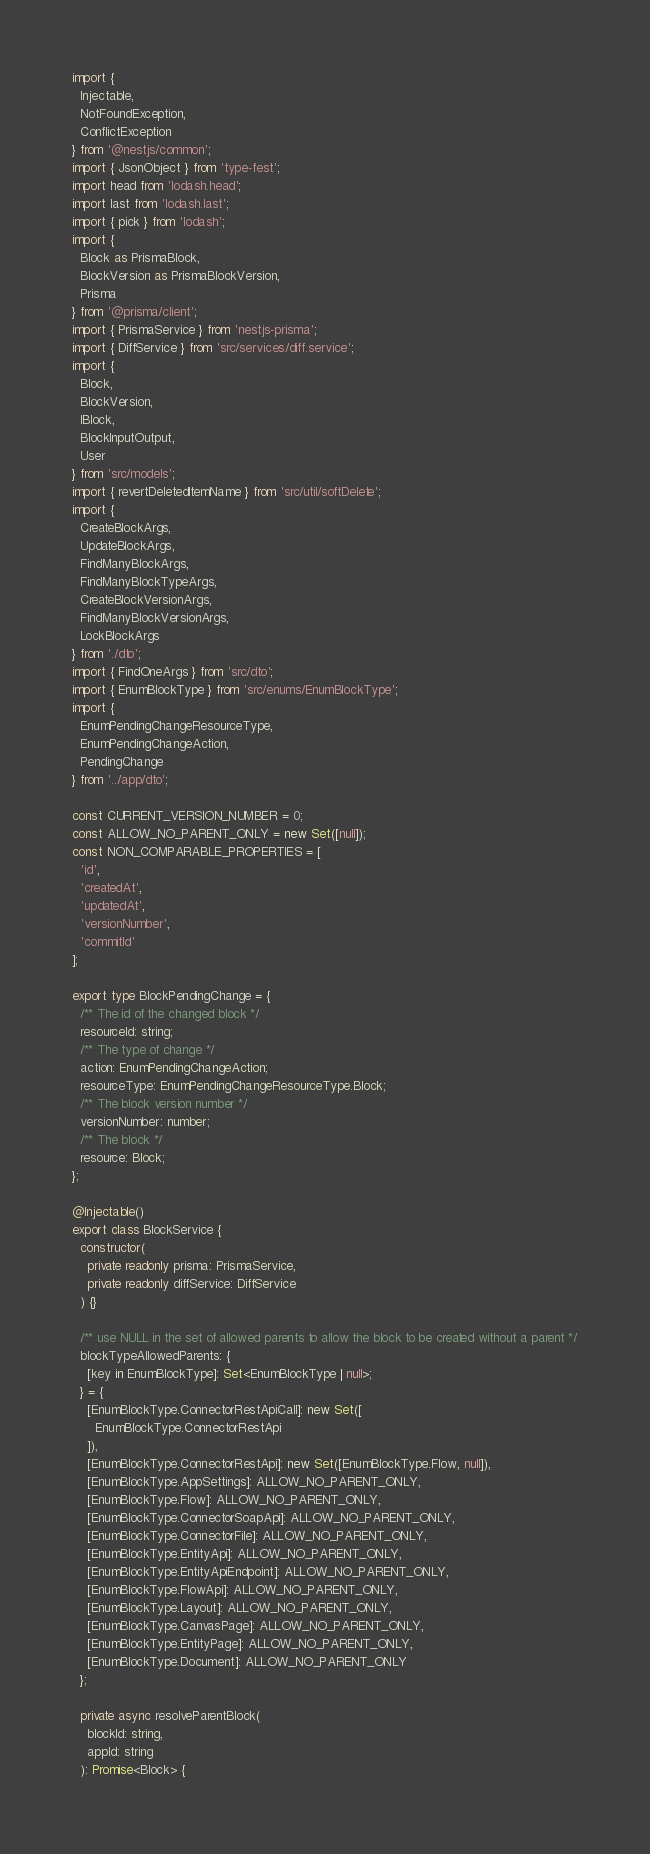<code> <loc_0><loc_0><loc_500><loc_500><_TypeScript_>import {
  Injectable,
  NotFoundException,
  ConflictException
} from '@nestjs/common';
import { JsonObject } from 'type-fest';
import head from 'lodash.head';
import last from 'lodash.last';
import { pick } from 'lodash';
import {
  Block as PrismaBlock,
  BlockVersion as PrismaBlockVersion,
  Prisma
} from '@prisma/client';
import { PrismaService } from 'nestjs-prisma';
import { DiffService } from 'src/services/diff.service';
import {
  Block,
  BlockVersion,
  IBlock,
  BlockInputOutput,
  User
} from 'src/models';
import { revertDeletedItemName } from 'src/util/softDelete';
import {
  CreateBlockArgs,
  UpdateBlockArgs,
  FindManyBlockArgs,
  FindManyBlockTypeArgs,
  CreateBlockVersionArgs,
  FindManyBlockVersionArgs,
  LockBlockArgs
} from './dto';
import { FindOneArgs } from 'src/dto';
import { EnumBlockType } from 'src/enums/EnumBlockType';
import {
  EnumPendingChangeResourceType,
  EnumPendingChangeAction,
  PendingChange
} from '../app/dto';

const CURRENT_VERSION_NUMBER = 0;
const ALLOW_NO_PARENT_ONLY = new Set([null]);
const NON_COMPARABLE_PROPERTIES = [
  'id',
  'createdAt',
  'updatedAt',
  'versionNumber',
  'commitId'
];

export type BlockPendingChange = {
  /** The id of the changed block */
  resourceId: string;
  /** The type of change */
  action: EnumPendingChangeAction;
  resourceType: EnumPendingChangeResourceType.Block;
  /** The block version number */
  versionNumber: number;
  /** The block */
  resource: Block;
};

@Injectable()
export class BlockService {
  constructor(
    private readonly prisma: PrismaService,
    private readonly diffService: DiffService
  ) {}

  /** use NULL in the set of allowed parents to allow the block to be created without a parent */
  blockTypeAllowedParents: {
    [key in EnumBlockType]: Set<EnumBlockType | null>;
  } = {
    [EnumBlockType.ConnectorRestApiCall]: new Set([
      EnumBlockType.ConnectorRestApi
    ]),
    [EnumBlockType.ConnectorRestApi]: new Set([EnumBlockType.Flow, null]),
    [EnumBlockType.AppSettings]: ALLOW_NO_PARENT_ONLY,
    [EnumBlockType.Flow]: ALLOW_NO_PARENT_ONLY,
    [EnumBlockType.ConnectorSoapApi]: ALLOW_NO_PARENT_ONLY,
    [EnumBlockType.ConnectorFile]: ALLOW_NO_PARENT_ONLY,
    [EnumBlockType.EntityApi]: ALLOW_NO_PARENT_ONLY,
    [EnumBlockType.EntityApiEndpoint]: ALLOW_NO_PARENT_ONLY,
    [EnumBlockType.FlowApi]: ALLOW_NO_PARENT_ONLY,
    [EnumBlockType.Layout]: ALLOW_NO_PARENT_ONLY,
    [EnumBlockType.CanvasPage]: ALLOW_NO_PARENT_ONLY,
    [EnumBlockType.EntityPage]: ALLOW_NO_PARENT_ONLY,
    [EnumBlockType.Document]: ALLOW_NO_PARENT_ONLY
  };

  private async resolveParentBlock(
    blockId: string,
    appId: string
  ): Promise<Block> {</code> 